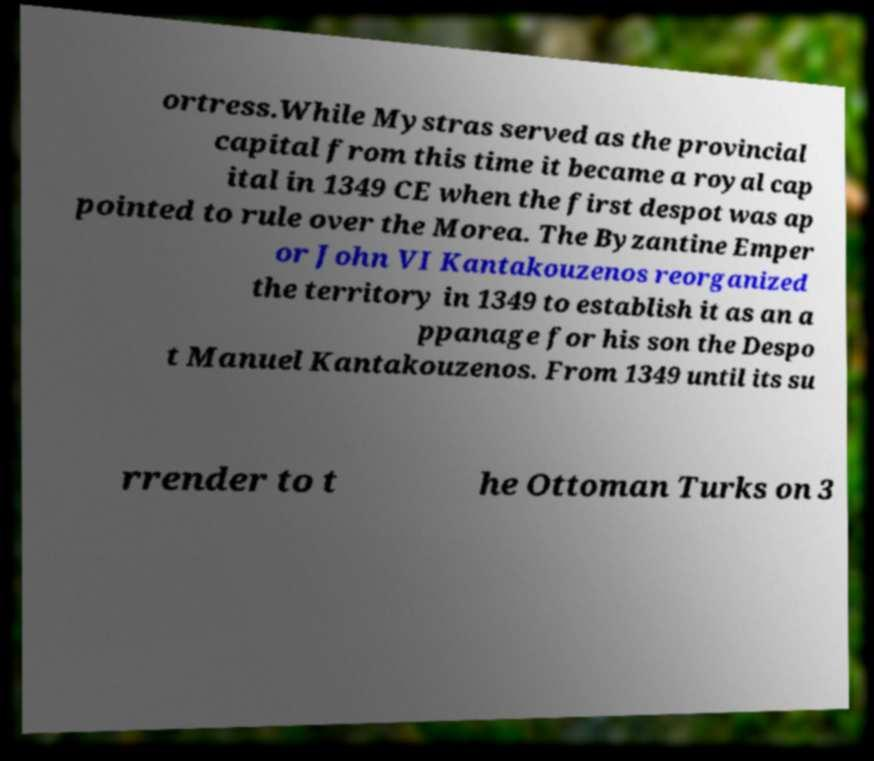Please read and relay the text visible in this image. What does it say? ortress.While Mystras served as the provincial capital from this time it became a royal cap ital in 1349 CE when the first despot was ap pointed to rule over the Morea. The Byzantine Emper or John VI Kantakouzenos reorganized the territory in 1349 to establish it as an a ppanage for his son the Despo t Manuel Kantakouzenos. From 1349 until its su rrender to t he Ottoman Turks on 3 